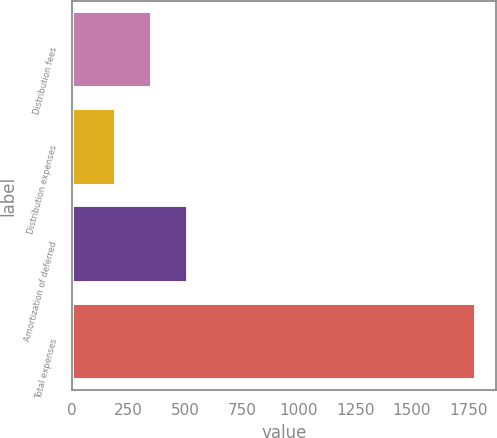Convert chart to OTSL. <chart><loc_0><loc_0><loc_500><loc_500><bar_chart><fcel>Distribution fees<fcel>Distribution expenses<fcel>Amortization of deferred<fcel>Total expenses<nl><fcel>352.9<fcel>194<fcel>511.8<fcel>1783<nl></chart> 